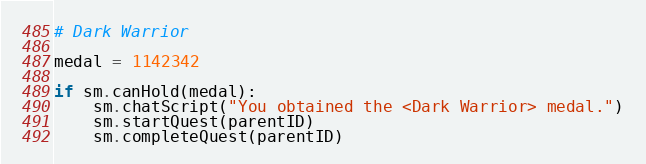<code> <loc_0><loc_0><loc_500><loc_500><_Python_># Dark Warrior

medal = 1142342

if sm.canHold(medal):
    sm.chatScript("You obtained the <Dark Warrior> medal.")
    sm.startQuest(parentID)
    sm.completeQuest(parentID)</code> 